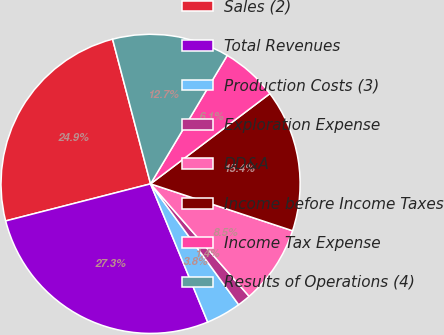<chart> <loc_0><loc_0><loc_500><loc_500><pie_chart><fcel>Sales (2)<fcel>Total Revenues<fcel>Production Costs (3)<fcel>Exploration Expense<fcel>DD&A<fcel>Income before Income Taxes<fcel>Income Tax Expense<fcel>Results of Operations (4)<nl><fcel>24.9%<fcel>27.25%<fcel>3.78%<fcel>1.43%<fcel>8.47%<fcel>15.38%<fcel>6.13%<fcel>12.65%<nl></chart> 